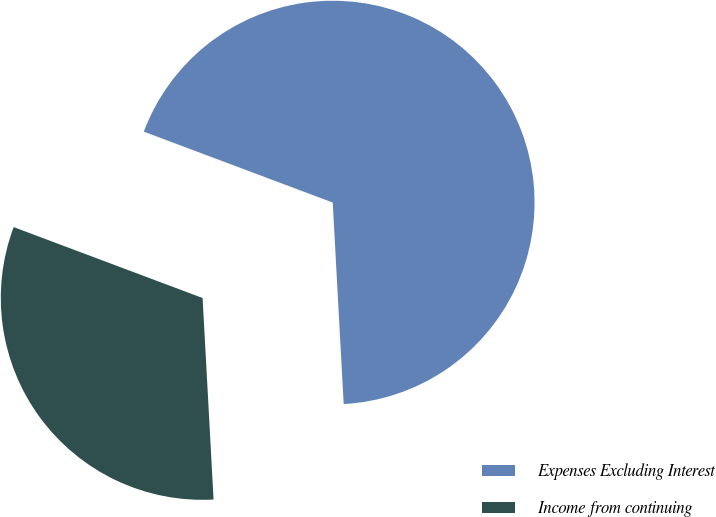Convert chart. <chart><loc_0><loc_0><loc_500><loc_500><pie_chart><fcel>Expenses Excluding Interest<fcel>Income from continuing<nl><fcel>68.42%<fcel>31.58%<nl></chart> 